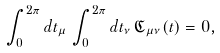<formula> <loc_0><loc_0><loc_500><loc_500>\int _ { 0 } ^ { 2 \pi } d t _ { \mu } \, \int _ { 0 } ^ { 2 \pi } d t _ { \nu } \, \mathfrak { C } _ { \mu \nu } ( t ) = 0 ,</formula> 